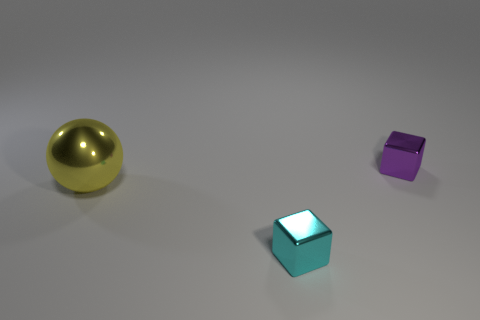Add 1 small brown cubes. How many objects exist? 4 Subtract all purple blocks. How many blocks are left? 1 Subtract all blocks. How many objects are left? 1 Add 1 big metal spheres. How many big metal spheres are left? 2 Add 1 small brown rubber blocks. How many small brown rubber blocks exist? 1 Subtract 1 cyan blocks. How many objects are left? 2 Subtract 1 blocks. How many blocks are left? 1 Subtract all purple cubes. Subtract all green cylinders. How many cubes are left? 1 Subtract all red matte balls. Subtract all small purple blocks. How many objects are left? 2 